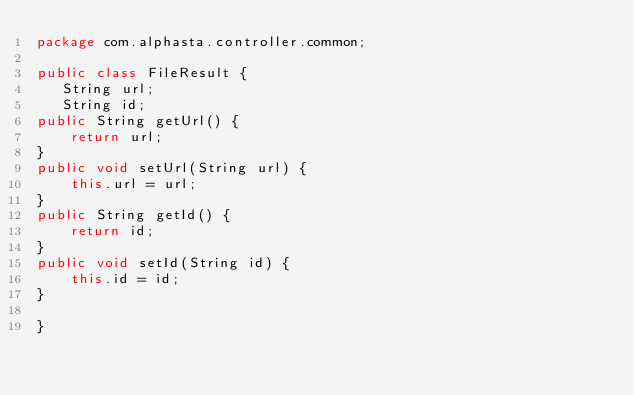Convert code to text. <code><loc_0><loc_0><loc_500><loc_500><_Java_>package com.alphasta.controller.common;

public class FileResult {
   String url;
   String id;
public String getUrl() {
	return url;
}
public void setUrl(String url) {
	this.url = url;
}
public String getId() {
	return id;
}
public void setId(String id) {
	this.id = id;
}
   
} 
</code> 